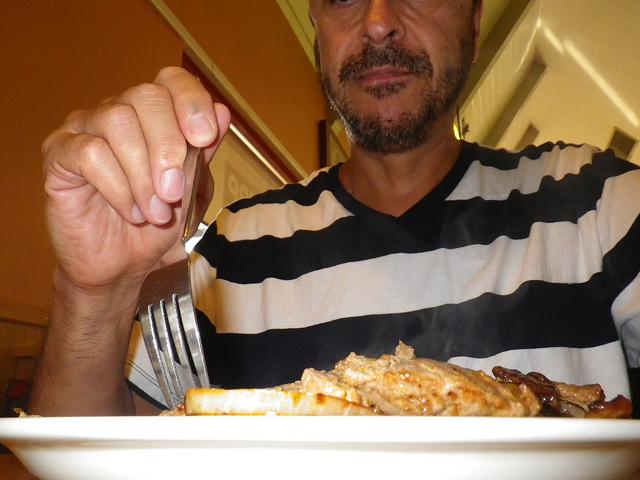Is the man using a folk?
Write a very short answer. Yes. Is the man wearing a striped shirt?
Answer briefly. Yes. Is he working?
Give a very brief answer. No. Was the man recently working as a laborer?
Concise answer only. No. 